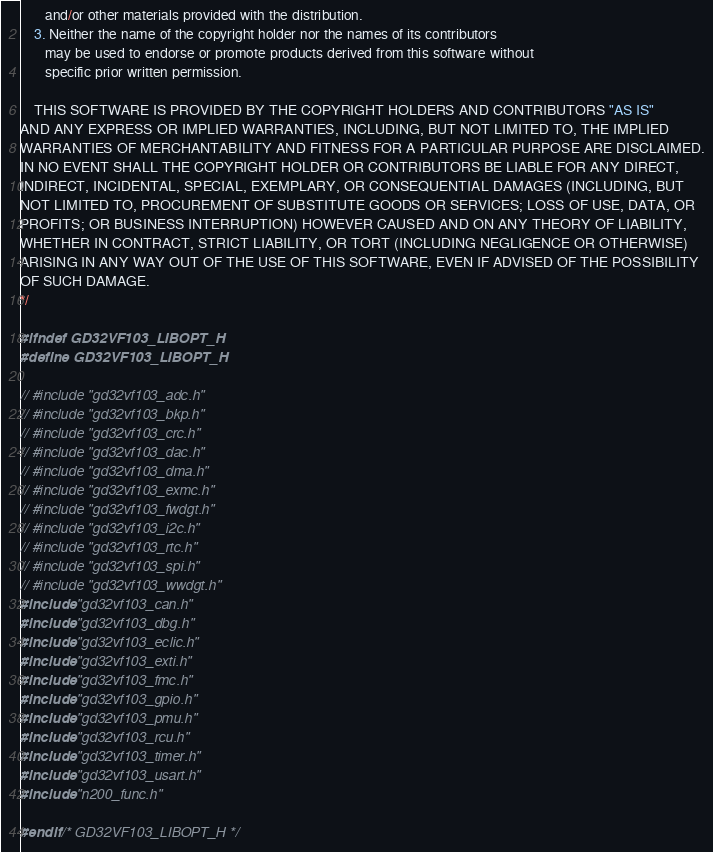Convert code to text. <code><loc_0><loc_0><loc_500><loc_500><_C_>       and/or other materials provided with the distribution.
    3. Neither the name of the copyright holder nor the names of its contributors
       may be used to endorse or promote products derived from this software without
       specific prior written permission.

    THIS SOFTWARE IS PROVIDED BY THE COPYRIGHT HOLDERS AND CONTRIBUTORS "AS IS"
AND ANY EXPRESS OR IMPLIED WARRANTIES, INCLUDING, BUT NOT LIMITED TO, THE IMPLIED
WARRANTIES OF MERCHANTABILITY AND FITNESS FOR A PARTICULAR PURPOSE ARE DISCLAIMED.
IN NO EVENT SHALL THE COPYRIGHT HOLDER OR CONTRIBUTORS BE LIABLE FOR ANY DIRECT,
INDIRECT, INCIDENTAL, SPECIAL, EXEMPLARY, OR CONSEQUENTIAL DAMAGES (INCLUDING, BUT
NOT LIMITED TO, PROCUREMENT OF SUBSTITUTE GOODS OR SERVICES; LOSS OF USE, DATA, OR
PROFITS; OR BUSINESS INTERRUPTION) HOWEVER CAUSED AND ON ANY THEORY OF LIABILITY,
WHETHER IN CONTRACT, STRICT LIABILITY, OR TORT (INCLUDING NEGLIGENCE OR OTHERWISE)
ARISING IN ANY WAY OUT OF THE USE OF THIS SOFTWARE, EVEN IF ADVISED OF THE POSSIBILITY
OF SUCH DAMAGE.
*/

#ifndef GD32VF103_LIBOPT_H
#define GD32VF103_LIBOPT_H

// #include "gd32vf103_adc.h"
// #include "gd32vf103_bkp.h"
// #include "gd32vf103_crc.h"
// #include "gd32vf103_dac.h"
// #include "gd32vf103_dma.h"
// #include "gd32vf103_exmc.h"
// #include "gd32vf103_fwdgt.h"
// #include "gd32vf103_i2c.h"
// #include "gd32vf103_rtc.h"
// #include "gd32vf103_spi.h"
// #include "gd32vf103_wwdgt.h"
#include "gd32vf103_can.h"
#include "gd32vf103_dbg.h"
#include "gd32vf103_eclic.h"
#include "gd32vf103_exti.h"
#include "gd32vf103_fmc.h"
#include "gd32vf103_gpio.h"
#include "gd32vf103_pmu.h"
#include "gd32vf103_rcu.h"
#include "gd32vf103_timer.h"
#include "gd32vf103_usart.h"
#include "n200_func.h"

#endif /* GD32VF103_LIBOPT_H */
</code> 